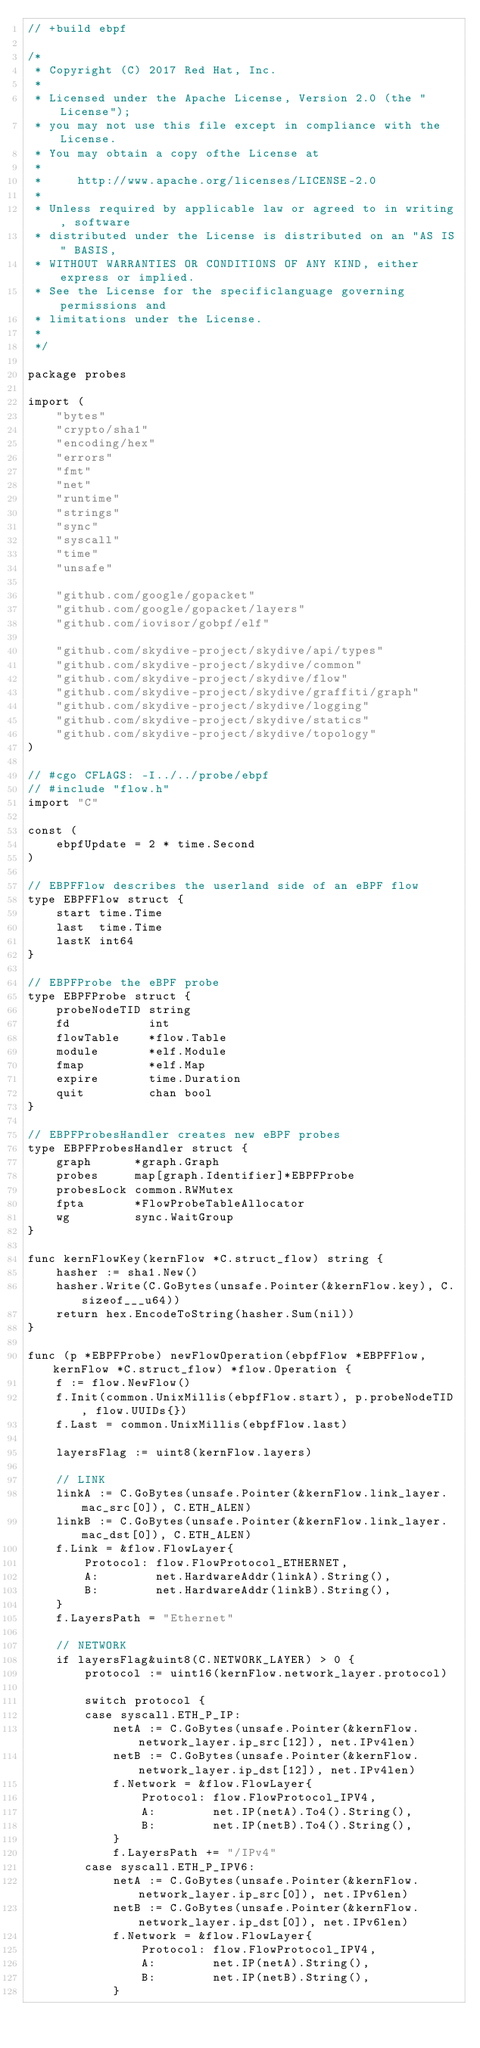Convert code to text. <code><loc_0><loc_0><loc_500><loc_500><_Go_>// +build ebpf

/*
 * Copyright (C) 2017 Red Hat, Inc.
 *
 * Licensed under the Apache License, Version 2.0 (the "License");
 * you may not use this file except in compliance with the License.
 * You may obtain a copy ofthe License at
 *
 *     http://www.apache.org/licenses/LICENSE-2.0
 *
 * Unless required by applicable law or agreed to in writing, software
 * distributed under the License is distributed on an "AS IS" BASIS,
 * WITHOUT WARRANTIES OR CONDITIONS OF ANY KIND, either express or implied.
 * See the License for the specificlanguage governing permissions and
 * limitations under the License.
 *
 */

package probes

import (
	"bytes"
	"crypto/sha1"
	"encoding/hex"
	"errors"
	"fmt"
	"net"
	"runtime"
	"strings"
	"sync"
	"syscall"
	"time"
	"unsafe"

	"github.com/google/gopacket"
	"github.com/google/gopacket/layers"
	"github.com/iovisor/gobpf/elf"

	"github.com/skydive-project/skydive/api/types"
	"github.com/skydive-project/skydive/common"
	"github.com/skydive-project/skydive/flow"
	"github.com/skydive-project/skydive/graffiti/graph"
	"github.com/skydive-project/skydive/logging"
	"github.com/skydive-project/skydive/statics"
	"github.com/skydive-project/skydive/topology"
)

// #cgo CFLAGS: -I../../probe/ebpf
// #include "flow.h"
import "C"

const (
	ebpfUpdate = 2 * time.Second
)

// EBPFFlow describes the userland side of an eBPF flow
type EBPFFlow struct {
	start time.Time
	last  time.Time
	lastK int64
}

// EBPFProbe the eBPF probe
type EBPFProbe struct {
	probeNodeTID string
	fd           int
	flowTable    *flow.Table
	module       *elf.Module
	fmap         *elf.Map
	expire       time.Duration
	quit         chan bool
}

// EBPFProbesHandler creates new eBPF probes
type EBPFProbesHandler struct {
	graph      *graph.Graph
	probes     map[graph.Identifier]*EBPFProbe
	probesLock common.RWMutex
	fpta       *FlowProbeTableAllocator
	wg         sync.WaitGroup
}

func kernFlowKey(kernFlow *C.struct_flow) string {
	hasher := sha1.New()
	hasher.Write(C.GoBytes(unsafe.Pointer(&kernFlow.key), C.sizeof___u64))
	return hex.EncodeToString(hasher.Sum(nil))
}

func (p *EBPFProbe) newFlowOperation(ebpfFlow *EBPFFlow, kernFlow *C.struct_flow) *flow.Operation {
	f := flow.NewFlow()
	f.Init(common.UnixMillis(ebpfFlow.start), p.probeNodeTID, flow.UUIDs{})
	f.Last = common.UnixMillis(ebpfFlow.last)

	layersFlag := uint8(kernFlow.layers)

	// LINK
	linkA := C.GoBytes(unsafe.Pointer(&kernFlow.link_layer.mac_src[0]), C.ETH_ALEN)
	linkB := C.GoBytes(unsafe.Pointer(&kernFlow.link_layer.mac_dst[0]), C.ETH_ALEN)
	f.Link = &flow.FlowLayer{
		Protocol: flow.FlowProtocol_ETHERNET,
		A:        net.HardwareAddr(linkA).String(),
		B:        net.HardwareAddr(linkB).String(),
	}
	f.LayersPath = "Ethernet"

	// NETWORK
	if layersFlag&uint8(C.NETWORK_LAYER) > 0 {
		protocol := uint16(kernFlow.network_layer.protocol)

		switch protocol {
		case syscall.ETH_P_IP:
			netA := C.GoBytes(unsafe.Pointer(&kernFlow.network_layer.ip_src[12]), net.IPv4len)
			netB := C.GoBytes(unsafe.Pointer(&kernFlow.network_layer.ip_dst[12]), net.IPv4len)
			f.Network = &flow.FlowLayer{
				Protocol: flow.FlowProtocol_IPV4,
				A:        net.IP(netA).To4().String(),
				B:        net.IP(netB).To4().String(),
			}
			f.LayersPath += "/IPv4"
		case syscall.ETH_P_IPV6:
			netA := C.GoBytes(unsafe.Pointer(&kernFlow.network_layer.ip_src[0]), net.IPv6len)
			netB := C.GoBytes(unsafe.Pointer(&kernFlow.network_layer.ip_dst[0]), net.IPv6len)
			f.Network = &flow.FlowLayer{
				Protocol: flow.FlowProtocol_IPV4,
				A:        net.IP(netA).String(),
				B:        net.IP(netB).String(),
			}</code> 